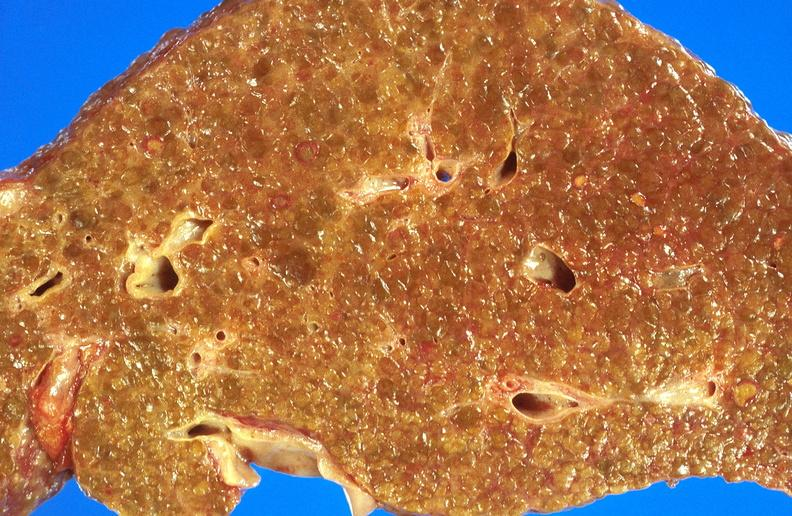what does this image show?
Answer the question using a single word or phrase. Alcoholic cirrhosis 